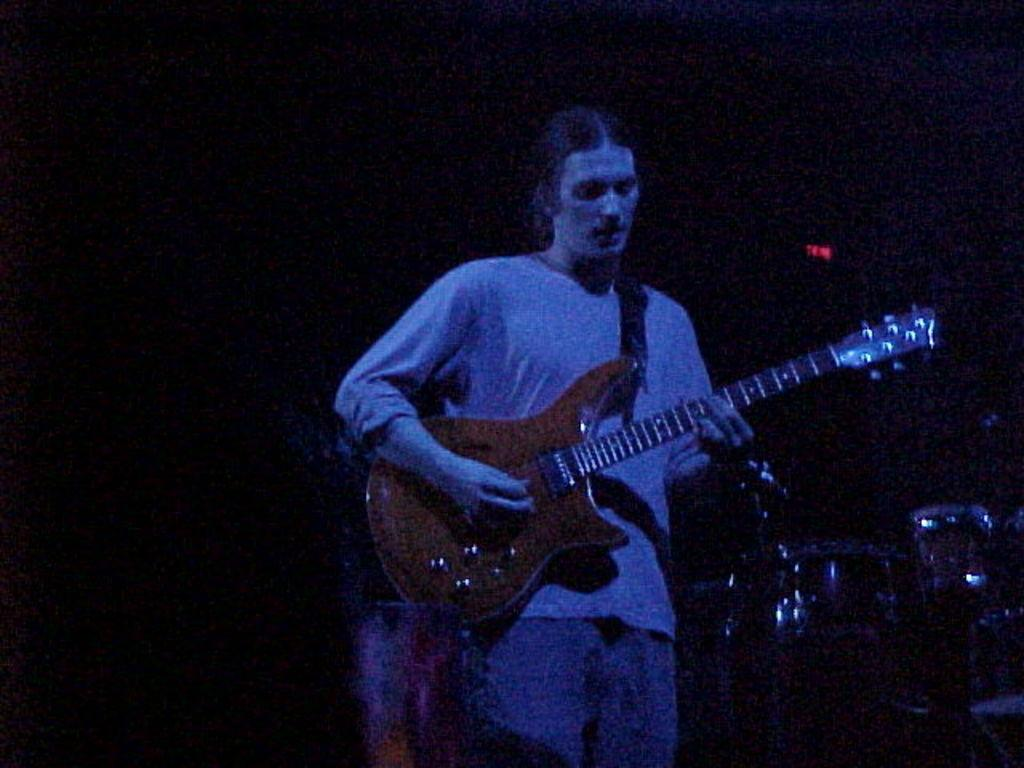What is the person in the image doing? The person is playing a guitar. What musical instrument can be seen in the background of the image? There are drums in the background of the image. How would you describe the lighting in the image? The background appears dark. What type of office furniture can be seen in the image? There is no office furniture present in the image; it features a person playing a guitar and drums in the background. 